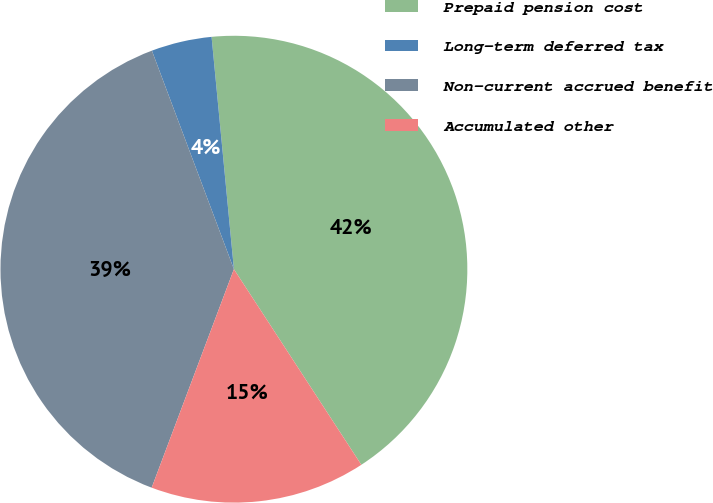Convert chart. <chart><loc_0><loc_0><loc_500><loc_500><pie_chart><fcel>Prepaid pension cost<fcel>Long-term deferred tax<fcel>Non-current accrued benefit<fcel>Accumulated other<nl><fcel>42.34%<fcel>4.19%<fcel>38.56%<fcel>14.92%<nl></chart> 